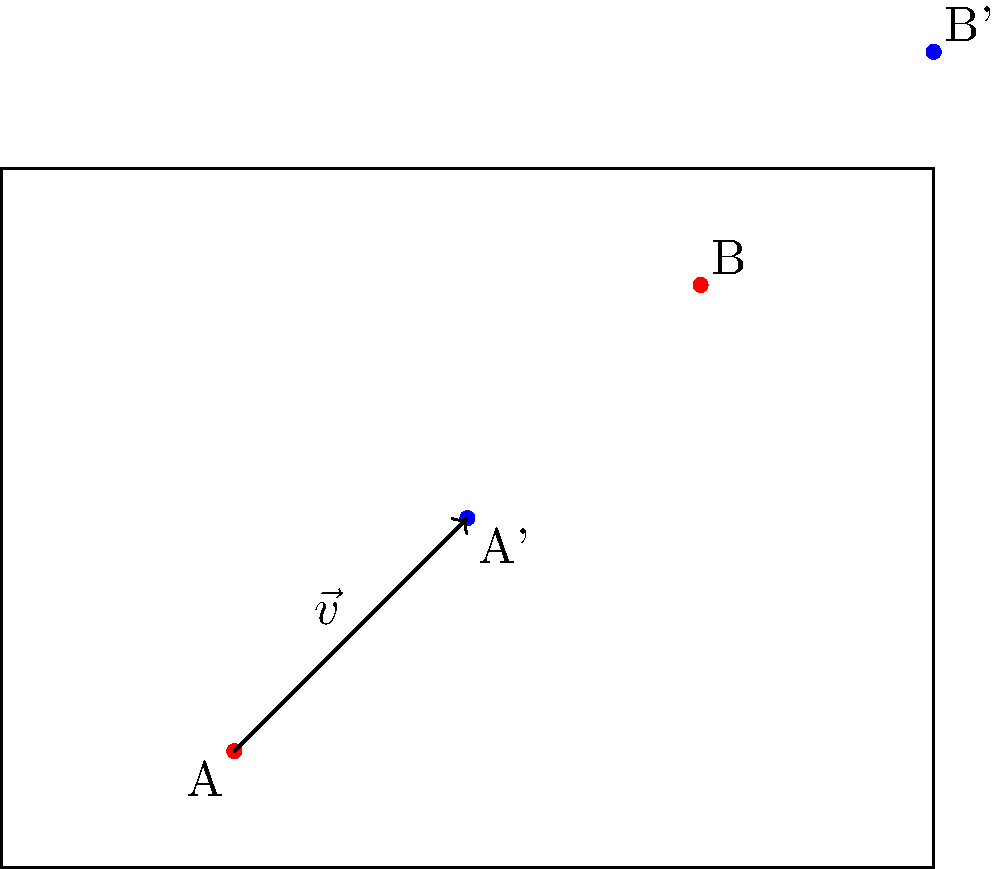En un plan de seguridad de un edificio, los puntos de salida de emergencia A(2,1) y B(6,5) se han trasladado 2 unidades a la derecha y 2 unidades hacia arriba. ¿Cuáles son las coordenadas de los nuevos puntos de salida A' y B'? Para resolver este problema, seguiremos estos pasos:

1. Identificar el vector de traslación:
   El vector de traslación es $\vec{v} = (2, 2)$, ya que los puntos se mueven 2 unidades a la derecha (eje x) y 2 unidades hacia arriba (eje y).

2. Aplicar la traslación al punto A(2,1):
   $A' = A + \vec{v} = (2,1) + (2,2) = (2+2, 1+2) = (4,3)$

3. Aplicar la traslación al punto B(6,5):
   $B' = B + \vec{v} = (6,5) + (2,2) = (6+2, 5+2) = (8,7)$

Por lo tanto, las nuevas coordenadas de los puntos de salida de emergencia son:
A': (4,3)
B': (8,7)
Answer: A'(4,3), B'(8,7) 